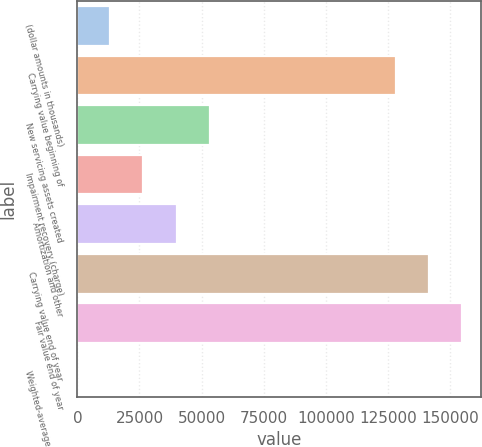<chart> <loc_0><loc_0><loc_500><loc_500><bar_chart><fcel>(dollar amounts in thousands)<fcel>Carrying value beginning of<fcel>New servicing assets created<fcel>Impairment recovery (charge)<fcel>Amortization and other<fcel>Carrying value end of year<fcel>Fair value end of year<fcel>Weighted-average life (years)<nl><fcel>13310.2<fcel>128064<fcel>53223.1<fcel>26614.5<fcel>39918.8<fcel>141368<fcel>154673<fcel>5.9<nl></chart> 